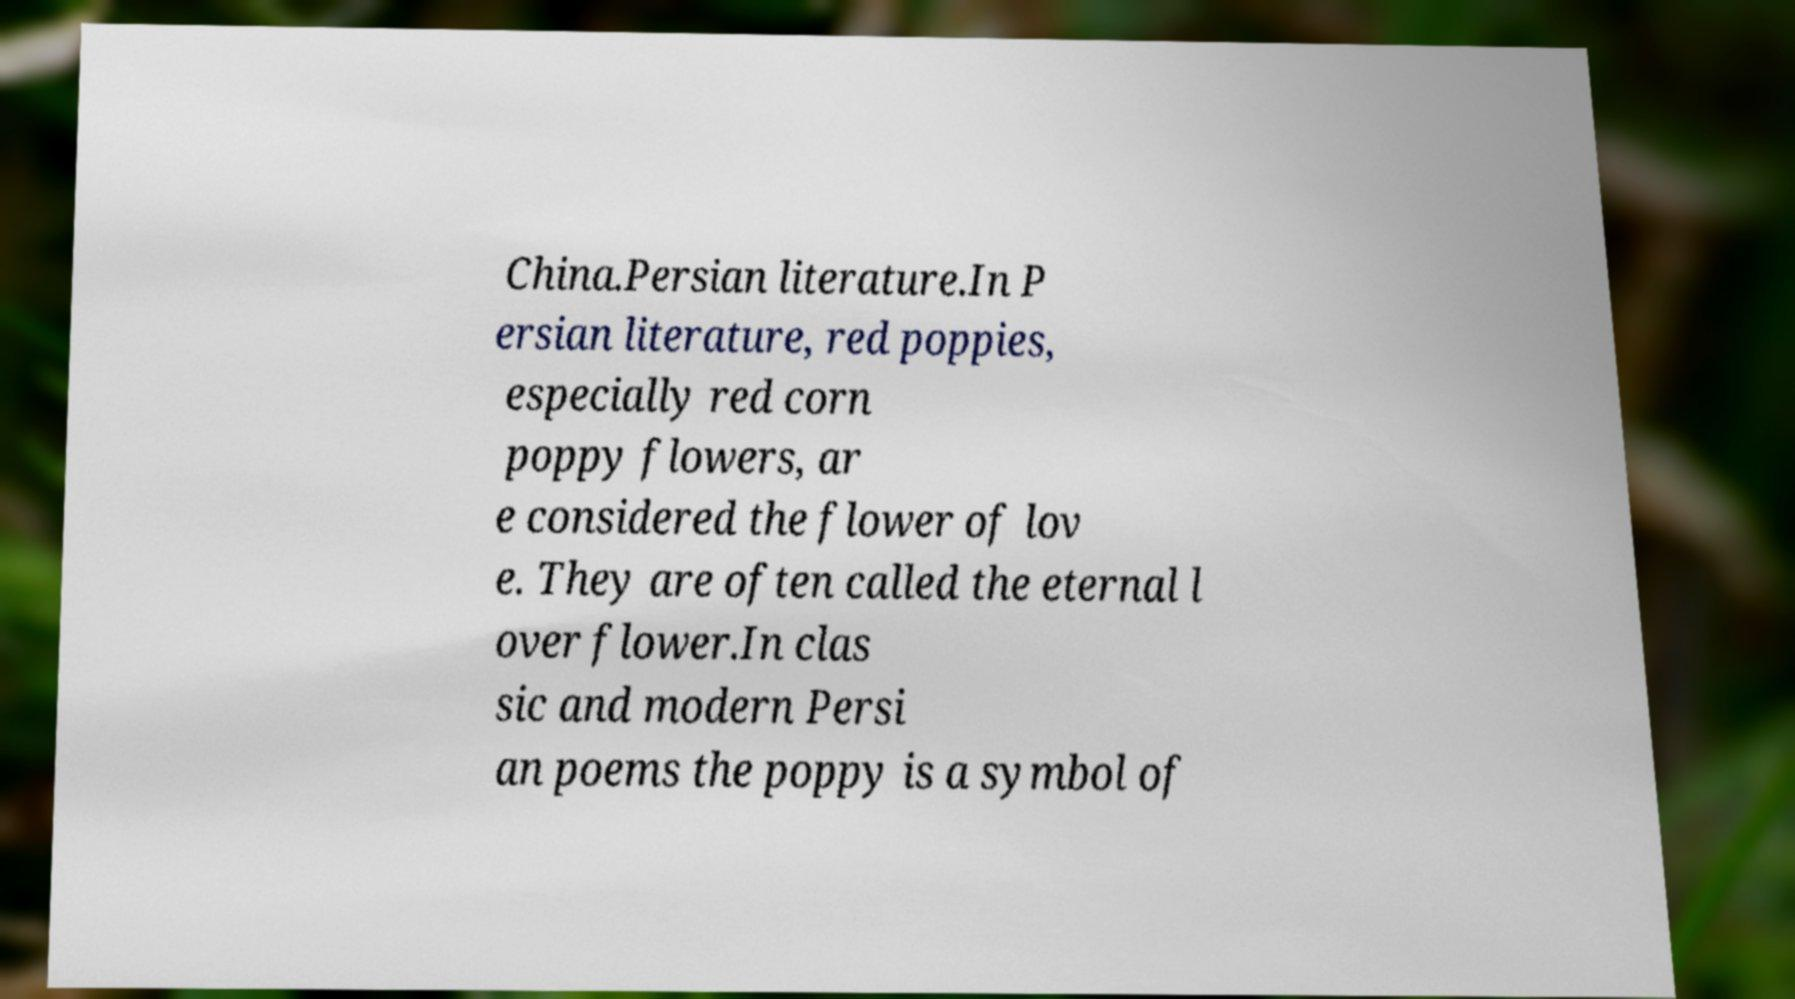Please read and relay the text visible in this image. What does it say? China.Persian literature.In P ersian literature, red poppies, especially red corn poppy flowers, ar e considered the flower of lov e. They are often called the eternal l over flower.In clas sic and modern Persi an poems the poppy is a symbol of 